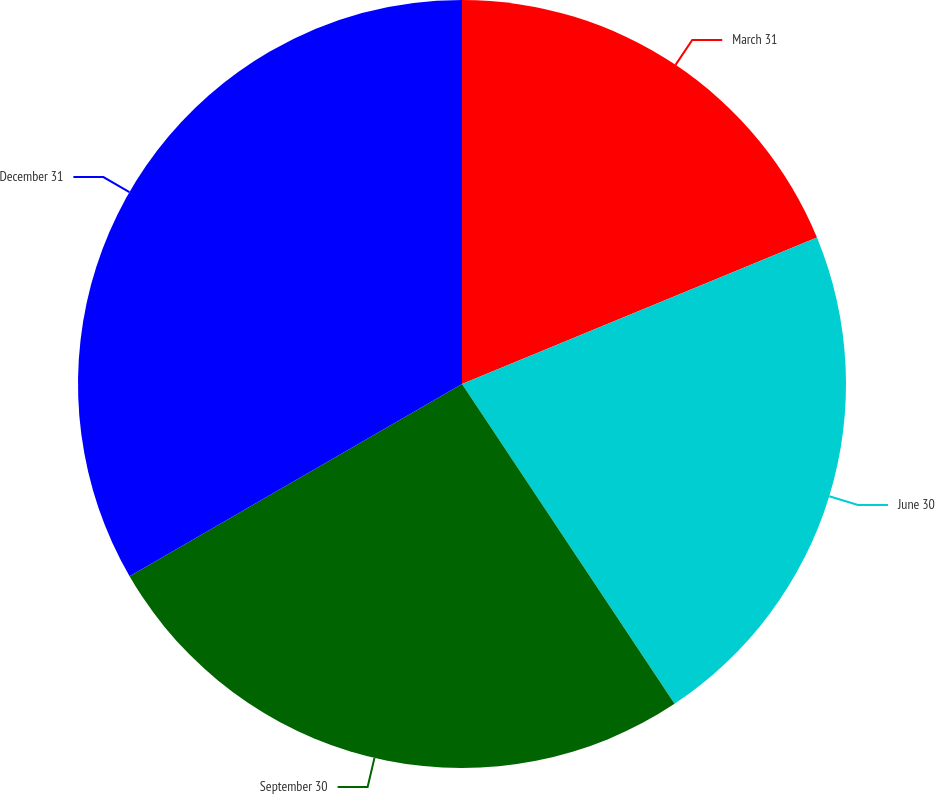<chart> <loc_0><loc_0><loc_500><loc_500><pie_chart><fcel>March 31<fcel>June 30<fcel>September 30<fcel>December 31<nl><fcel>18.77%<fcel>21.89%<fcel>25.99%<fcel>33.34%<nl></chart> 